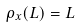<formula> <loc_0><loc_0><loc_500><loc_500>\rho _ { x } ( L ) = L</formula> 